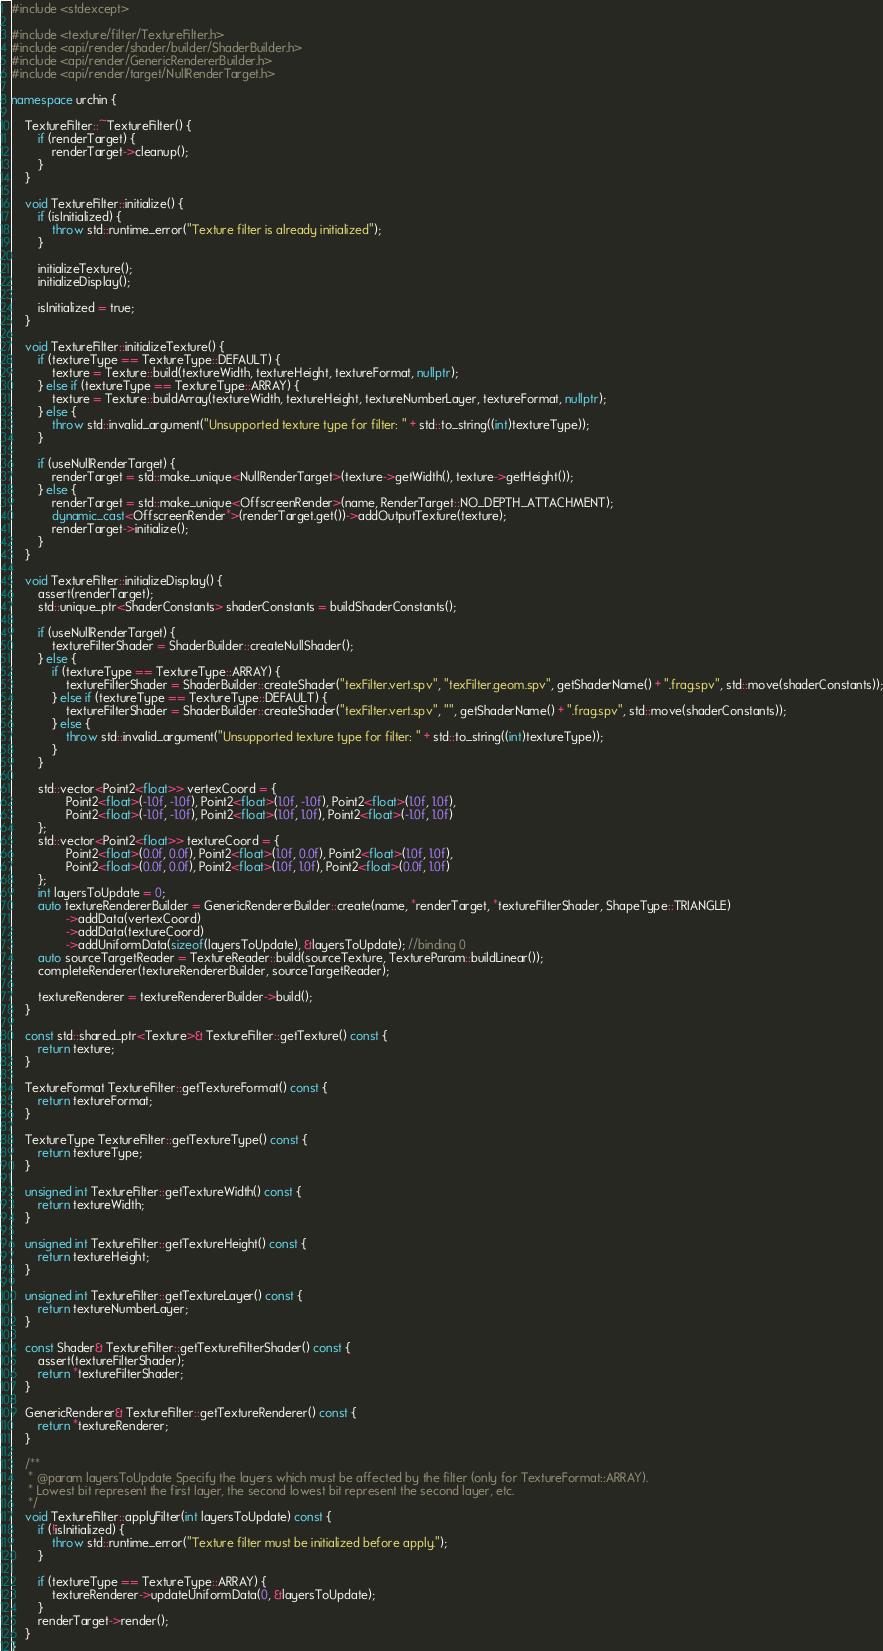Convert code to text. <code><loc_0><loc_0><loc_500><loc_500><_C++_>#include <stdexcept>

#include <texture/filter/TextureFilter.h>
#include <api/render/shader/builder/ShaderBuilder.h>
#include <api/render/GenericRendererBuilder.h>
#include <api/render/target/NullRenderTarget.h>

namespace urchin {

    TextureFilter::~TextureFilter() {
        if (renderTarget) {
            renderTarget->cleanup();
        }
    }

    void TextureFilter::initialize() {
        if (isInitialized) {
            throw std::runtime_error("Texture filter is already initialized");
        }

        initializeTexture();
        initializeDisplay();

        isInitialized = true;
    }

    void TextureFilter::initializeTexture() {
        if (textureType == TextureType::DEFAULT) {
            texture = Texture::build(textureWidth, textureHeight, textureFormat, nullptr);
        } else if (textureType == TextureType::ARRAY) {
            texture = Texture::buildArray(textureWidth, textureHeight, textureNumberLayer, textureFormat, nullptr);
        } else {
            throw std::invalid_argument("Unsupported texture type for filter: " + std::to_string((int)textureType));
        }

        if (useNullRenderTarget) {
            renderTarget = std::make_unique<NullRenderTarget>(texture->getWidth(), texture->getHeight());
        } else {
            renderTarget = std::make_unique<OffscreenRender>(name, RenderTarget::NO_DEPTH_ATTACHMENT);
            dynamic_cast<OffscreenRender*>(renderTarget.get())->addOutputTexture(texture);
            renderTarget->initialize();
        }
    }

    void TextureFilter::initializeDisplay() {
        assert(renderTarget);
        std::unique_ptr<ShaderConstants> shaderConstants = buildShaderConstants();

        if (useNullRenderTarget) {
            textureFilterShader = ShaderBuilder::createNullShader();
        } else {
            if (textureType == TextureType::ARRAY) {
                textureFilterShader = ShaderBuilder::createShader("texFilter.vert.spv", "texFilter.geom.spv", getShaderName() + ".frag.spv", std::move(shaderConstants));
            } else if (textureType == TextureType::DEFAULT) {
                textureFilterShader = ShaderBuilder::createShader("texFilter.vert.spv", "", getShaderName() + ".frag.spv", std::move(shaderConstants));
            } else {
                throw std::invalid_argument("Unsupported texture type for filter: " + std::to_string((int)textureType));
            }
        }

        std::vector<Point2<float>> vertexCoord = {
                Point2<float>(-1.0f, -1.0f), Point2<float>(1.0f, -1.0f), Point2<float>(1.0f, 1.0f),
                Point2<float>(-1.0f, -1.0f), Point2<float>(1.0f, 1.0f), Point2<float>(-1.0f, 1.0f)
        };
        std::vector<Point2<float>> textureCoord = {
                Point2<float>(0.0f, 0.0f), Point2<float>(1.0f, 0.0f), Point2<float>(1.0f, 1.0f),
                Point2<float>(0.0f, 0.0f), Point2<float>(1.0f, 1.0f), Point2<float>(0.0f, 1.0f)
        };
        int layersToUpdate = 0;
        auto textureRendererBuilder = GenericRendererBuilder::create(name, *renderTarget, *textureFilterShader, ShapeType::TRIANGLE)
                ->addData(vertexCoord)
                ->addData(textureCoord)
                ->addUniformData(sizeof(layersToUpdate), &layersToUpdate); //binding 0
        auto sourceTargetReader = TextureReader::build(sourceTexture, TextureParam::buildLinear());
        completeRenderer(textureRendererBuilder, sourceTargetReader);

        textureRenderer = textureRendererBuilder->build();
    }

    const std::shared_ptr<Texture>& TextureFilter::getTexture() const {
        return texture;
    }

    TextureFormat TextureFilter::getTextureFormat() const {
        return textureFormat;
    }

    TextureType TextureFilter::getTextureType() const {
        return textureType;
    }

    unsigned int TextureFilter::getTextureWidth() const {
        return textureWidth;
    }

    unsigned int TextureFilter::getTextureHeight() const {
        return textureHeight;
    }

    unsigned int TextureFilter::getTextureLayer() const {
        return textureNumberLayer;
    }

    const Shader& TextureFilter::getTextureFilterShader() const {
        assert(textureFilterShader);
        return *textureFilterShader;
    }

    GenericRenderer& TextureFilter::getTextureRenderer() const {
        return *textureRenderer;
    }

    /**
     * @param layersToUpdate Specify the layers which must be affected by the filter (only for TextureFormat::ARRAY).
     * Lowest bit represent the first layer, the second lowest bit represent the second layer, etc.
     */
    void TextureFilter::applyFilter(int layersToUpdate) const {
        if (!isInitialized) {
            throw std::runtime_error("Texture filter must be initialized before apply.");
        }

        if (textureType == TextureType::ARRAY) {
            textureRenderer->updateUniformData(0, &layersToUpdate);
        }
        renderTarget->render();
    }
}
</code> 